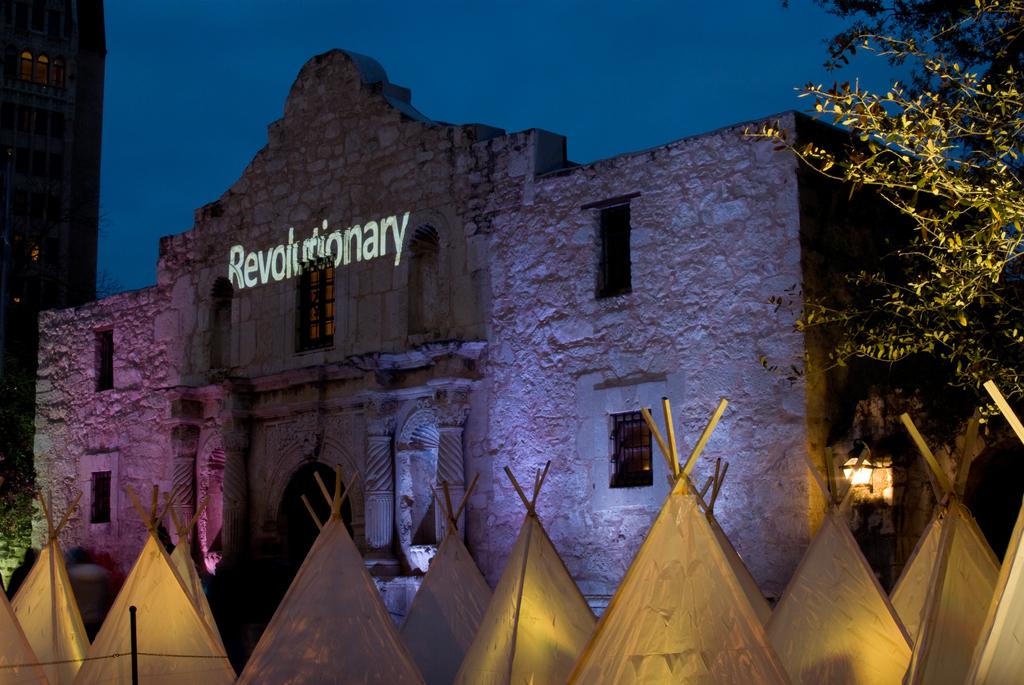What is written on the top of the building?
Provide a short and direct response. Revolutionary. 